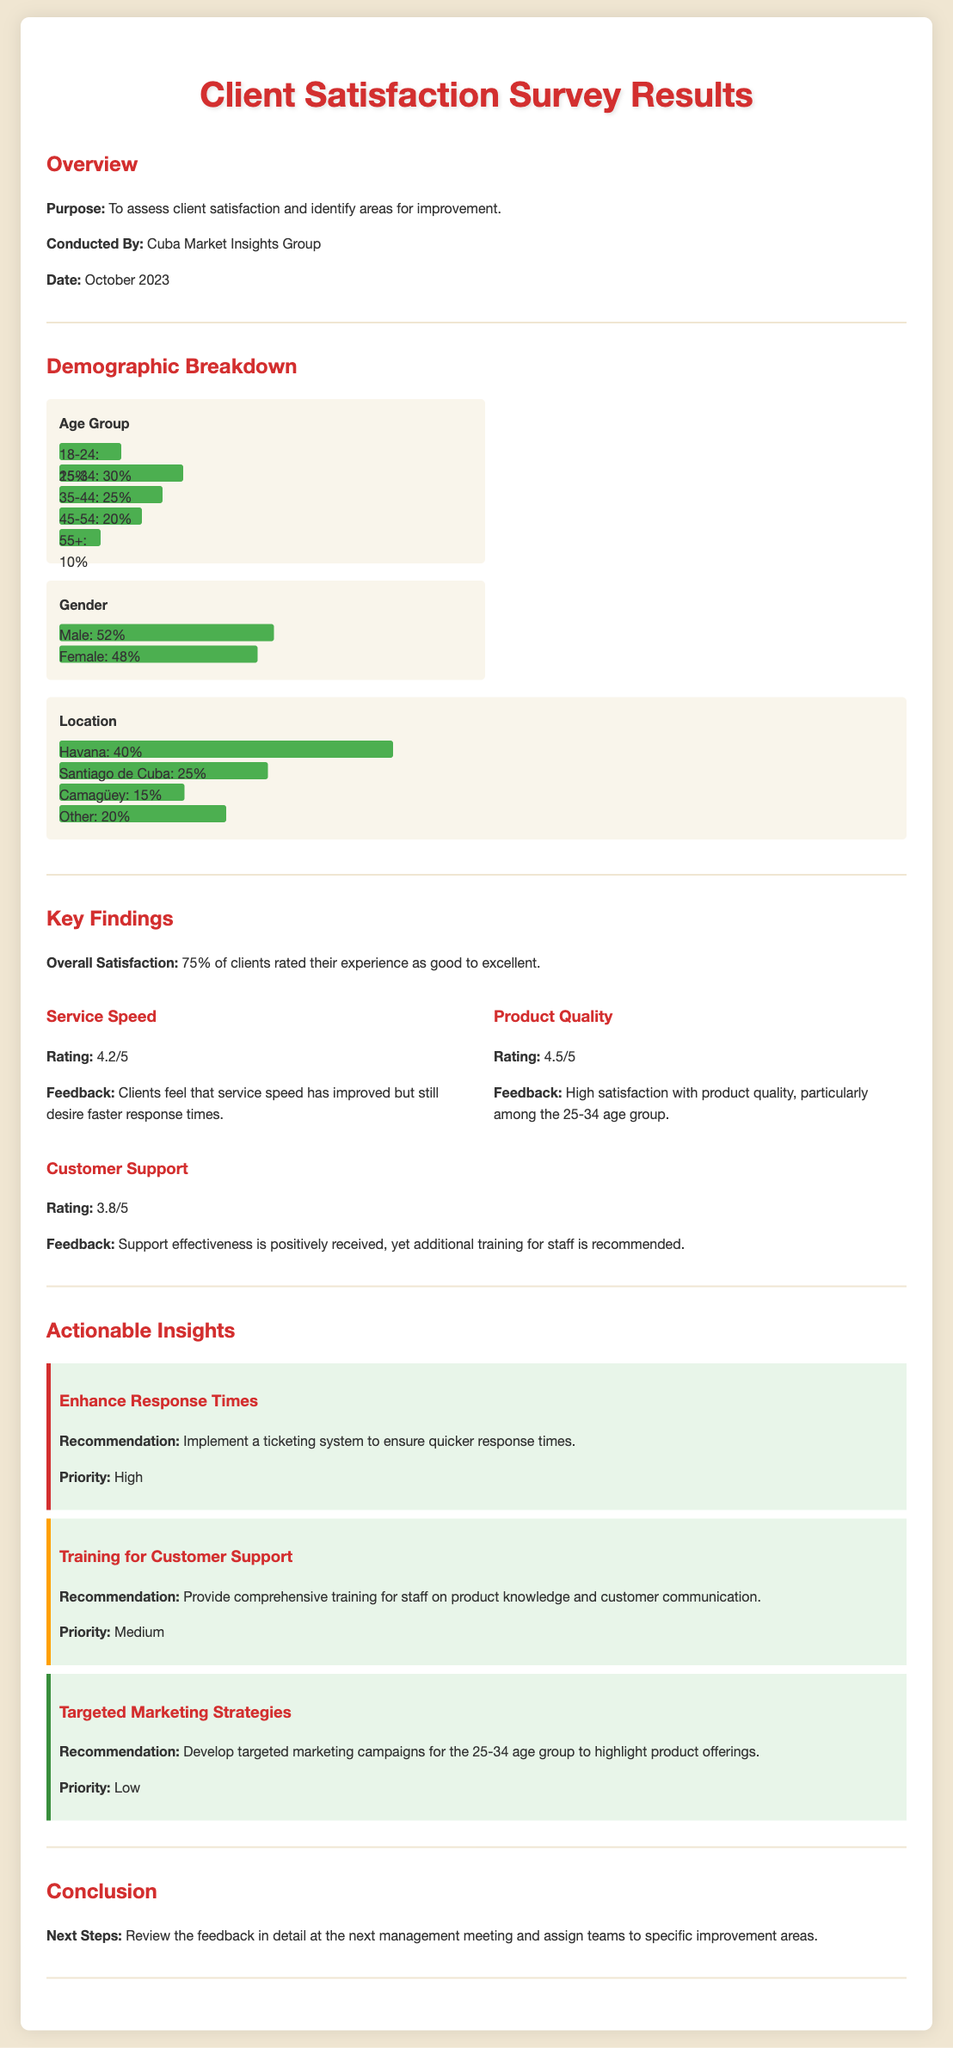What is the overall satisfaction percentage? The overall satisfaction percentage is stated in the document, indicating how many clients rated their experience positively.
Answer: 75% Which age group has the highest percentage of respondents? This can be determined by comparing the percentages in the age group chart.
Answer: 25-34 What is the rating for Service Speed? The rating for Service Speed is provided in the key findings section and is a numerical value.
Answer: 4.2/5 What demographic has the highest representation in terms of location? The data for locations is displayed, showing which area has the highest client percentage.
Answer: Havana What is the priority level for enhancing response times? The document specifies the priority assigned to this actionable insight, indicating its importance.
Answer: High What feedback is given regarding Product Quality? The document includes client feedback regarding this aspect, which reflects their satisfaction.
Answer: High satisfaction with product quality How many clients rated Customer Support as effective? The document contains a rating that reflects client perception of customer support effectiveness.
Answer: 3.8/5 What is the main recommendation for Customer Support staff? The text shares a specific recommendation aimed at improving staff effectiveness.
Answer: Comprehensive training Which age group is suggested for targeted marketing strategies? The insights include a recommendation indicating which demographic should be targeted for marketing.
Answer: 25-34 